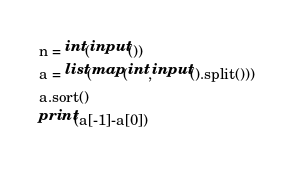Convert code to text. <code><loc_0><loc_0><loc_500><loc_500><_Python_>n = int(input())
a = list(map(int,input().split()))
a.sort()
print(a[-1]-a[0])</code> 